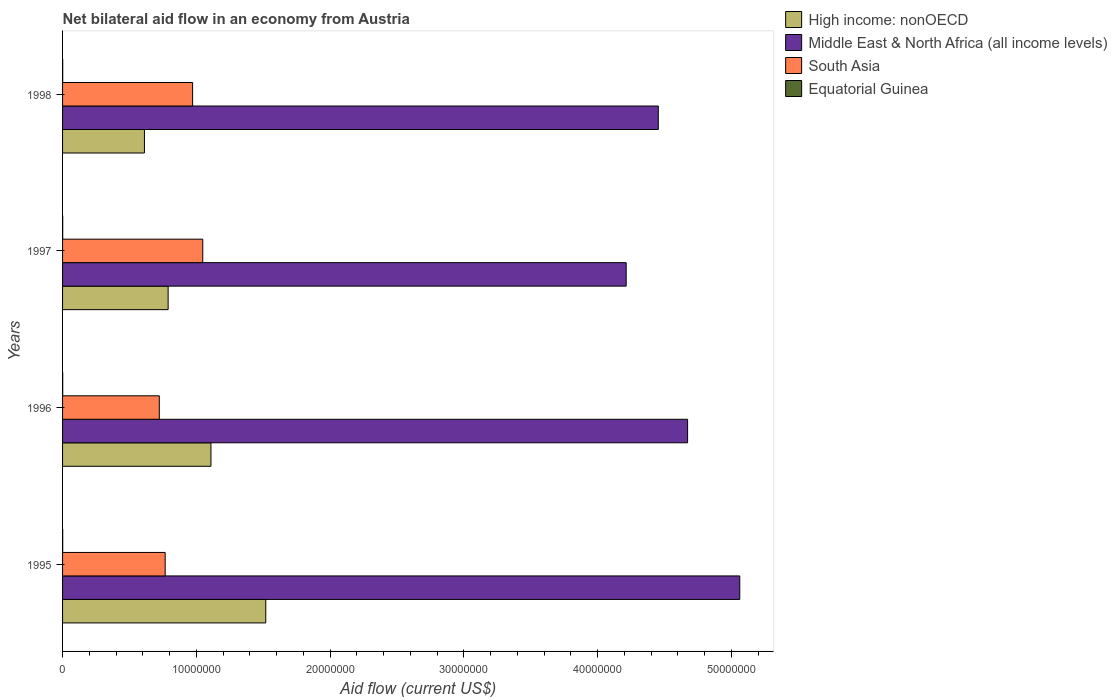Across all years, what is the maximum net bilateral aid flow in South Asia?
Your response must be concise. 1.05e+07. In which year was the net bilateral aid flow in Middle East & North Africa (all income levels) maximum?
Offer a very short reply. 1995. In which year was the net bilateral aid flow in Middle East & North Africa (all income levels) minimum?
Provide a succinct answer. 1997. What is the total net bilateral aid flow in Equatorial Guinea in the graph?
Keep it short and to the point. 4.00e+04. What is the difference between the net bilateral aid flow in South Asia in 1996 and that in 1998?
Provide a succinct answer. -2.49e+06. What is the difference between the net bilateral aid flow in High income: nonOECD in 1995 and the net bilateral aid flow in Equatorial Guinea in 1997?
Make the answer very short. 1.52e+07. In the year 1995, what is the difference between the net bilateral aid flow in Equatorial Guinea and net bilateral aid flow in South Asia?
Make the answer very short. -7.66e+06. In how many years, is the net bilateral aid flow in Equatorial Guinea greater than 30000000 US$?
Give a very brief answer. 0. What is the ratio of the net bilateral aid flow in High income: nonOECD in 1995 to that in 1997?
Provide a succinct answer. 1.93. What is the difference between the highest and the second highest net bilateral aid flow in South Asia?
Offer a terse response. 7.60e+05. In how many years, is the net bilateral aid flow in High income: nonOECD greater than the average net bilateral aid flow in High income: nonOECD taken over all years?
Give a very brief answer. 2. Is it the case that in every year, the sum of the net bilateral aid flow in Middle East & North Africa (all income levels) and net bilateral aid flow in Equatorial Guinea is greater than the sum of net bilateral aid flow in South Asia and net bilateral aid flow in High income: nonOECD?
Ensure brevity in your answer.  Yes. What does the 1st bar from the top in 1995 represents?
Your answer should be very brief. Equatorial Guinea. What does the 2nd bar from the bottom in 1998 represents?
Offer a terse response. Middle East & North Africa (all income levels). Is it the case that in every year, the sum of the net bilateral aid flow in Middle East & North Africa (all income levels) and net bilateral aid flow in South Asia is greater than the net bilateral aid flow in High income: nonOECD?
Offer a terse response. Yes. How many bars are there?
Provide a short and direct response. 16. Are all the bars in the graph horizontal?
Keep it short and to the point. Yes. What is the difference between two consecutive major ticks on the X-axis?
Give a very brief answer. 1.00e+07. Are the values on the major ticks of X-axis written in scientific E-notation?
Your answer should be very brief. No. Does the graph contain any zero values?
Offer a terse response. No. Does the graph contain grids?
Make the answer very short. No. How many legend labels are there?
Ensure brevity in your answer.  4. What is the title of the graph?
Your response must be concise. Net bilateral aid flow in an economy from Austria. Does "Jamaica" appear as one of the legend labels in the graph?
Your response must be concise. No. What is the Aid flow (current US$) in High income: nonOECD in 1995?
Provide a short and direct response. 1.52e+07. What is the Aid flow (current US$) in Middle East & North Africa (all income levels) in 1995?
Provide a short and direct response. 5.06e+07. What is the Aid flow (current US$) of South Asia in 1995?
Your response must be concise. 7.67e+06. What is the Aid flow (current US$) in Equatorial Guinea in 1995?
Give a very brief answer. 10000. What is the Aid flow (current US$) of High income: nonOECD in 1996?
Offer a very short reply. 1.11e+07. What is the Aid flow (current US$) in Middle East & North Africa (all income levels) in 1996?
Offer a very short reply. 4.67e+07. What is the Aid flow (current US$) of South Asia in 1996?
Make the answer very short. 7.23e+06. What is the Aid flow (current US$) in High income: nonOECD in 1997?
Your response must be concise. 7.89e+06. What is the Aid flow (current US$) in Middle East & North Africa (all income levels) in 1997?
Your response must be concise. 4.21e+07. What is the Aid flow (current US$) of South Asia in 1997?
Provide a short and direct response. 1.05e+07. What is the Aid flow (current US$) of Equatorial Guinea in 1997?
Your response must be concise. 10000. What is the Aid flow (current US$) in High income: nonOECD in 1998?
Your response must be concise. 6.12e+06. What is the Aid flow (current US$) in Middle East & North Africa (all income levels) in 1998?
Offer a terse response. 4.45e+07. What is the Aid flow (current US$) of South Asia in 1998?
Provide a short and direct response. 9.72e+06. What is the Aid flow (current US$) of Equatorial Guinea in 1998?
Your response must be concise. 10000. Across all years, what is the maximum Aid flow (current US$) in High income: nonOECD?
Offer a very short reply. 1.52e+07. Across all years, what is the maximum Aid flow (current US$) in Middle East & North Africa (all income levels)?
Make the answer very short. 5.06e+07. Across all years, what is the maximum Aid flow (current US$) in South Asia?
Keep it short and to the point. 1.05e+07. Across all years, what is the minimum Aid flow (current US$) in High income: nonOECD?
Offer a terse response. 6.12e+06. Across all years, what is the minimum Aid flow (current US$) of Middle East & North Africa (all income levels)?
Provide a short and direct response. 4.21e+07. Across all years, what is the minimum Aid flow (current US$) in South Asia?
Ensure brevity in your answer.  7.23e+06. What is the total Aid flow (current US$) in High income: nonOECD in the graph?
Your answer should be very brief. 4.03e+07. What is the total Aid flow (current US$) of Middle East & North Africa (all income levels) in the graph?
Your answer should be very brief. 1.84e+08. What is the total Aid flow (current US$) of South Asia in the graph?
Give a very brief answer. 3.51e+07. What is the difference between the Aid flow (current US$) in High income: nonOECD in 1995 and that in 1996?
Keep it short and to the point. 4.10e+06. What is the difference between the Aid flow (current US$) of Middle East & North Africa (all income levels) in 1995 and that in 1996?
Provide a succinct answer. 3.90e+06. What is the difference between the Aid flow (current US$) of High income: nonOECD in 1995 and that in 1997?
Your response must be concise. 7.30e+06. What is the difference between the Aid flow (current US$) of Middle East & North Africa (all income levels) in 1995 and that in 1997?
Offer a very short reply. 8.49e+06. What is the difference between the Aid flow (current US$) in South Asia in 1995 and that in 1997?
Provide a short and direct response. -2.81e+06. What is the difference between the Aid flow (current US$) of Equatorial Guinea in 1995 and that in 1997?
Provide a short and direct response. 0. What is the difference between the Aid flow (current US$) in High income: nonOECD in 1995 and that in 1998?
Keep it short and to the point. 9.07e+06. What is the difference between the Aid flow (current US$) in Middle East & North Africa (all income levels) in 1995 and that in 1998?
Your answer should be very brief. 6.09e+06. What is the difference between the Aid flow (current US$) in South Asia in 1995 and that in 1998?
Provide a succinct answer. -2.05e+06. What is the difference between the Aid flow (current US$) in High income: nonOECD in 1996 and that in 1997?
Your response must be concise. 3.20e+06. What is the difference between the Aid flow (current US$) in Middle East & North Africa (all income levels) in 1996 and that in 1997?
Give a very brief answer. 4.59e+06. What is the difference between the Aid flow (current US$) in South Asia in 1996 and that in 1997?
Your response must be concise. -3.25e+06. What is the difference between the Aid flow (current US$) in High income: nonOECD in 1996 and that in 1998?
Provide a short and direct response. 4.97e+06. What is the difference between the Aid flow (current US$) of Middle East & North Africa (all income levels) in 1996 and that in 1998?
Make the answer very short. 2.19e+06. What is the difference between the Aid flow (current US$) of South Asia in 1996 and that in 1998?
Your answer should be compact. -2.49e+06. What is the difference between the Aid flow (current US$) of Equatorial Guinea in 1996 and that in 1998?
Keep it short and to the point. 0. What is the difference between the Aid flow (current US$) in High income: nonOECD in 1997 and that in 1998?
Keep it short and to the point. 1.77e+06. What is the difference between the Aid flow (current US$) of Middle East & North Africa (all income levels) in 1997 and that in 1998?
Ensure brevity in your answer.  -2.40e+06. What is the difference between the Aid flow (current US$) in South Asia in 1997 and that in 1998?
Provide a short and direct response. 7.60e+05. What is the difference between the Aid flow (current US$) in Equatorial Guinea in 1997 and that in 1998?
Ensure brevity in your answer.  0. What is the difference between the Aid flow (current US$) in High income: nonOECD in 1995 and the Aid flow (current US$) in Middle East & North Africa (all income levels) in 1996?
Give a very brief answer. -3.15e+07. What is the difference between the Aid flow (current US$) in High income: nonOECD in 1995 and the Aid flow (current US$) in South Asia in 1996?
Ensure brevity in your answer.  7.96e+06. What is the difference between the Aid flow (current US$) of High income: nonOECD in 1995 and the Aid flow (current US$) of Equatorial Guinea in 1996?
Ensure brevity in your answer.  1.52e+07. What is the difference between the Aid flow (current US$) of Middle East & North Africa (all income levels) in 1995 and the Aid flow (current US$) of South Asia in 1996?
Give a very brief answer. 4.34e+07. What is the difference between the Aid flow (current US$) in Middle East & North Africa (all income levels) in 1995 and the Aid flow (current US$) in Equatorial Guinea in 1996?
Make the answer very short. 5.06e+07. What is the difference between the Aid flow (current US$) in South Asia in 1995 and the Aid flow (current US$) in Equatorial Guinea in 1996?
Offer a terse response. 7.66e+06. What is the difference between the Aid flow (current US$) in High income: nonOECD in 1995 and the Aid flow (current US$) in Middle East & North Africa (all income levels) in 1997?
Offer a very short reply. -2.69e+07. What is the difference between the Aid flow (current US$) in High income: nonOECD in 1995 and the Aid flow (current US$) in South Asia in 1997?
Provide a short and direct response. 4.71e+06. What is the difference between the Aid flow (current US$) in High income: nonOECD in 1995 and the Aid flow (current US$) in Equatorial Guinea in 1997?
Your response must be concise. 1.52e+07. What is the difference between the Aid flow (current US$) in Middle East & North Africa (all income levels) in 1995 and the Aid flow (current US$) in South Asia in 1997?
Your answer should be very brief. 4.01e+07. What is the difference between the Aid flow (current US$) of Middle East & North Africa (all income levels) in 1995 and the Aid flow (current US$) of Equatorial Guinea in 1997?
Keep it short and to the point. 5.06e+07. What is the difference between the Aid flow (current US$) in South Asia in 1995 and the Aid flow (current US$) in Equatorial Guinea in 1997?
Give a very brief answer. 7.66e+06. What is the difference between the Aid flow (current US$) of High income: nonOECD in 1995 and the Aid flow (current US$) of Middle East & North Africa (all income levels) in 1998?
Your answer should be very brief. -2.93e+07. What is the difference between the Aid flow (current US$) in High income: nonOECD in 1995 and the Aid flow (current US$) in South Asia in 1998?
Your answer should be compact. 5.47e+06. What is the difference between the Aid flow (current US$) in High income: nonOECD in 1995 and the Aid flow (current US$) in Equatorial Guinea in 1998?
Provide a short and direct response. 1.52e+07. What is the difference between the Aid flow (current US$) in Middle East & North Africa (all income levels) in 1995 and the Aid flow (current US$) in South Asia in 1998?
Your answer should be very brief. 4.09e+07. What is the difference between the Aid flow (current US$) in Middle East & North Africa (all income levels) in 1995 and the Aid flow (current US$) in Equatorial Guinea in 1998?
Provide a short and direct response. 5.06e+07. What is the difference between the Aid flow (current US$) of South Asia in 1995 and the Aid flow (current US$) of Equatorial Guinea in 1998?
Give a very brief answer. 7.66e+06. What is the difference between the Aid flow (current US$) in High income: nonOECD in 1996 and the Aid flow (current US$) in Middle East & North Africa (all income levels) in 1997?
Provide a succinct answer. -3.10e+07. What is the difference between the Aid flow (current US$) in High income: nonOECD in 1996 and the Aid flow (current US$) in Equatorial Guinea in 1997?
Offer a terse response. 1.11e+07. What is the difference between the Aid flow (current US$) in Middle East & North Africa (all income levels) in 1996 and the Aid flow (current US$) in South Asia in 1997?
Provide a short and direct response. 3.62e+07. What is the difference between the Aid flow (current US$) of Middle East & North Africa (all income levels) in 1996 and the Aid flow (current US$) of Equatorial Guinea in 1997?
Offer a very short reply. 4.67e+07. What is the difference between the Aid flow (current US$) in South Asia in 1996 and the Aid flow (current US$) in Equatorial Guinea in 1997?
Make the answer very short. 7.22e+06. What is the difference between the Aid flow (current US$) of High income: nonOECD in 1996 and the Aid flow (current US$) of Middle East & North Africa (all income levels) in 1998?
Your response must be concise. -3.34e+07. What is the difference between the Aid flow (current US$) in High income: nonOECD in 1996 and the Aid flow (current US$) in South Asia in 1998?
Provide a short and direct response. 1.37e+06. What is the difference between the Aid flow (current US$) in High income: nonOECD in 1996 and the Aid flow (current US$) in Equatorial Guinea in 1998?
Ensure brevity in your answer.  1.11e+07. What is the difference between the Aid flow (current US$) in Middle East & North Africa (all income levels) in 1996 and the Aid flow (current US$) in South Asia in 1998?
Your answer should be compact. 3.70e+07. What is the difference between the Aid flow (current US$) of Middle East & North Africa (all income levels) in 1996 and the Aid flow (current US$) of Equatorial Guinea in 1998?
Give a very brief answer. 4.67e+07. What is the difference between the Aid flow (current US$) in South Asia in 1996 and the Aid flow (current US$) in Equatorial Guinea in 1998?
Offer a very short reply. 7.22e+06. What is the difference between the Aid flow (current US$) in High income: nonOECD in 1997 and the Aid flow (current US$) in Middle East & North Africa (all income levels) in 1998?
Give a very brief answer. -3.66e+07. What is the difference between the Aid flow (current US$) in High income: nonOECD in 1997 and the Aid flow (current US$) in South Asia in 1998?
Ensure brevity in your answer.  -1.83e+06. What is the difference between the Aid flow (current US$) of High income: nonOECD in 1997 and the Aid flow (current US$) of Equatorial Guinea in 1998?
Give a very brief answer. 7.88e+06. What is the difference between the Aid flow (current US$) in Middle East & North Africa (all income levels) in 1997 and the Aid flow (current US$) in South Asia in 1998?
Ensure brevity in your answer.  3.24e+07. What is the difference between the Aid flow (current US$) of Middle East & North Africa (all income levels) in 1997 and the Aid flow (current US$) of Equatorial Guinea in 1998?
Your response must be concise. 4.21e+07. What is the difference between the Aid flow (current US$) of South Asia in 1997 and the Aid flow (current US$) of Equatorial Guinea in 1998?
Make the answer very short. 1.05e+07. What is the average Aid flow (current US$) in High income: nonOECD per year?
Offer a very short reply. 1.01e+07. What is the average Aid flow (current US$) in Middle East & North Africa (all income levels) per year?
Your answer should be very brief. 4.60e+07. What is the average Aid flow (current US$) in South Asia per year?
Give a very brief answer. 8.78e+06. In the year 1995, what is the difference between the Aid flow (current US$) in High income: nonOECD and Aid flow (current US$) in Middle East & North Africa (all income levels)?
Make the answer very short. -3.54e+07. In the year 1995, what is the difference between the Aid flow (current US$) of High income: nonOECD and Aid flow (current US$) of South Asia?
Offer a terse response. 7.52e+06. In the year 1995, what is the difference between the Aid flow (current US$) of High income: nonOECD and Aid flow (current US$) of Equatorial Guinea?
Offer a terse response. 1.52e+07. In the year 1995, what is the difference between the Aid flow (current US$) in Middle East & North Africa (all income levels) and Aid flow (current US$) in South Asia?
Offer a very short reply. 4.30e+07. In the year 1995, what is the difference between the Aid flow (current US$) in Middle East & North Africa (all income levels) and Aid flow (current US$) in Equatorial Guinea?
Keep it short and to the point. 5.06e+07. In the year 1995, what is the difference between the Aid flow (current US$) in South Asia and Aid flow (current US$) in Equatorial Guinea?
Offer a terse response. 7.66e+06. In the year 1996, what is the difference between the Aid flow (current US$) in High income: nonOECD and Aid flow (current US$) in Middle East & North Africa (all income levels)?
Provide a short and direct response. -3.56e+07. In the year 1996, what is the difference between the Aid flow (current US$) of High income: nonOECD and Aid flow (current US$) of South Asia?
Keep it short and to the point. 3.86e+06. In the year 1996, what is the difference between the Aid flow (current US$) of High income: nonOECD and Aid flow (current US$) of Equatorial Guinea?
Make the answer very short. 1.11e+07. In the year 1996, what is the difference between the Aid flow (current US$) of Middle East & North Africa (all income levels) and Aid flow (current US$) of South Asia?
Provide a succinct answer. 3.95e+07. In the year 1996, what is the difference between the Aid flow (current US$) of Middle East & North Africa (all income levels) and Aid flow (current US$) of Equatorial Guinea?
Your response must be concise. 4.67e+07. In the year 1996, what is the difference between the Aid flow (current US$) in South Asia and Aid flow (current US$) in Equatorial Guinea?
Offer a very short reply. 7.22e+06. In the year 1997, what is the difference between the Aid flow (current US$) of High income: nonOECD and Aid flow (current US$) of Middle East & North Africa (all income levels)?
Your answer should be very brief. -3.42e+07. In the year 1997, what is the difference between the Aid flow (current US$) of High income: nonOECD and Aid flow (current US$) of South Asia?
Give a very brief answer. -2.59e+06. In the year 1997, what is the difference between the Aid flow (current US$) in High income: nonOECD and Aid flow (current US$) in Equatorial Guinea?
Your response must be concise. 7.88e+06. In the year 1997, what is the difference between the Aid flow (current US$) in Middle East & North Africa (all income levels) and Aid flow (current US$) in South Asia?
Offer a very short reply. 3.16e+07. In the year 1997, what is the difference between the Aid flow (current US$) of Middle East & North Africa (all income levels) and Aid flow (current US$) of Equatorial Guinea?
Provide a succinct answer. 4.21e+07. In the year 1997, what is the difference between the Aid flow (current US$) in South Asia and Aid flow (current US$) in Equatorial Guinea?
Your answer should be very brief. 1.05e+07. In the year 1998, what is the difference between the Aid flow (current US$) in High income: nonOECD and Aid flow (current US$) in Middle East & North Africa (all income levels)?
Make the answer very short. -3.84e+07. In the year 1998, what is the difference between the Aid flow (current US$) in High income: nonOECD and Aid flow (current US$) in South Asia?
Your response must be concise. -3.60e+06. In the year 1998, what is the difference between the Aid flow (current US$) in High income: nonOECD and Aid flow (current US$) in Equatorial Guinea?
Offer a terse response. 6.11e+06. In the year 1998, what is the difference between the Aid flow (current US$) in Middle East & North Africa (all income levels) and Aid flow (current US$) in South Asia?
Offer a very short reply. 3.48e+07. In the year 1998, what is the difference between the Aid flow (current US$) of Middle East & North Africa (all income levels) and Aid flow (current US$) of Equatorial Guinea?
Give a very brief answer. 4.45e+07. In the year 1998, what is the difference between the Aid flow (current US$) of South Asia and Aid flow (current US$) of Equatorial Guinea?
Your answer should be very brief. 9.71e+06. What is the ratio of the Aid flow (current US$) of High income: nonOECD in 1995 to that in 1996?
Offer a terse response. 1.37. What is the ratio of the Aid flow (current US$) in Middle East & North Africa (all income levels) in 1995 to that in 1996?
Offer a very short reply. 1.08. What is the ratio of the Aid flow (current US$) in South Asia in 1995 to that in 1996?
Give a very brief answer. 1.06. What is the ratio of the Aid flow (current US$) in Equatorial Guinea in 1995 to that in 1996?
Offer a very short reply. 1. What is the ratio of the Aid flow (current US$) in High income: nonOECD in 1995 to that in 1997?
Your answer should be very brief. 1.93. What is the ratio of the Aid flow (current US$) in Middle East & North Africa (all income levels) in 1995 to that in 1997?
Your answer should be very brief. 1.2. What is the ratio of the Aid flow (current US$) of South Asia in 1995 to that in 1997?
Give a very brief answer. 0.73. What is the ratio of the Aid flow (current US$) in High income: nonOECD in 1995 to that in 1998?
Your answer should be very brief. 2.48. What is the ratio of the Aid flow (current US$) in Middle East & North Africa (all income levels) in 1995 to that in 1998?
Make the answer very short. 1.14. What is the ratio of the Aid flow (current US$) in South Asia in 1995 to that in 1998?
Offer a very short reply. 0.79. What is the ratio of the Aid flow (current US$) in Equatorial Guinea in 1995 to that in 1998?
Provide a short and direct response. 1. What is the ratio of the Aid flow (current US$) of High income: nonOECD in 1996 to that in 1997?
Offer a very short reply. 1.41. What is the ratio of the Aid flow (current US$) in Middle East & North Africa (all income levels) in 1996 to that in 1997?
Keep it short and to the point. 1.11. What is the ratio of the Aid flow (current US$) in South Asia in 1996 to that in 1997?
Offer a very short reply. 0.69. What is the ratio of the Aid flow (current US$) of High income: nonOECD in 1996 to that in 1998?
Your answer should be very brief. 1.81. What is the ratio of the Aid flow (current US$) in Middle East & North Africa (all income levels) in 1996 to that in 1998?
Your answer should be very brief. 1.05. What is the ratio of the Aid flow (current US$) in South Asia in 1996 to that in 1998?
Your answer should be very brief. 0.74. What is the ratio of the Aid flow (current US$) of High income: nonOECD in 1997 to that in 1998?
Make the answer very short. 1.29. What is the ratio of the Aid flow (current US$) of Middle East & North Africa (all income levels) in 1997 to that in 1998?
Provide a succinct answer. 0.95. What is the ratio of the Aid flow (current US$) of South Asia in 1997 to that in 1998?
Offer a very short reply. 1.08. What is the difference between the highest and the second highest Aid flow (current US$) of High income: nonOECD?
Offer a very short reply. 4.10e+06. What is the difference between the highest and the second highest Aid flow (current US$) in Middle East & North Africa (all income levels)?
Provide a short and direct response. 3.90e+06. What is the difference between the highest and the second highest Aid flow (current US$) in South Asia?
Your answer should be compact. 7.60e+05. What is the difference between the highest and the second highest Aid flow (current US$) in Equatorial Guinea?
Keep it short and to the point. 0. What is the difference between the highest and the lowest Aid flow (current US$) in High income: nonOECD?
Offer a very short reply. 9.07e+06. What is the difference between the highest and the lowest Aid flow (current US$) of Middle East & North Africa (all income levels)?
Provide a succinct answer. 8.49e+06. What is the difference between the highest and the lowest Aid flow (current US$) of South Asia?
Ensure brevity in your answer.  3.25e+06. 